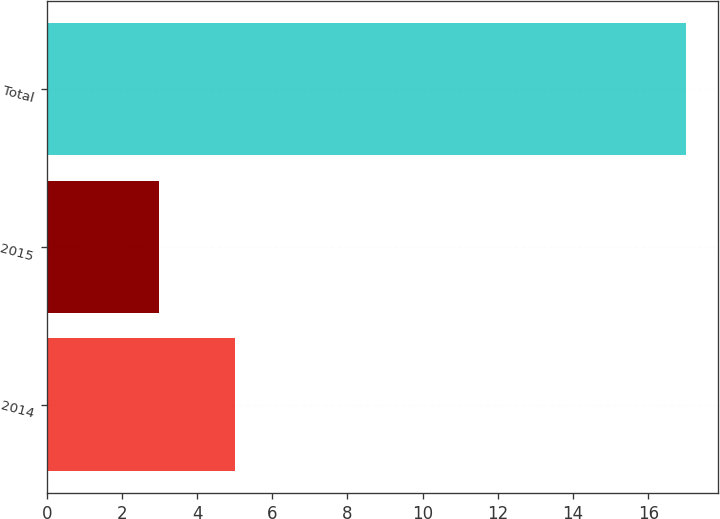Convert chart. <chart><loc_0><loc_0><loc_500><loc_500><bar_chart><fcel>2014<fcel>2015<fcel>Total<nl><fcel>5<fcel>3<fcel>17<nl></chart> 